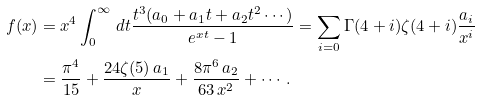<formula> <loc_0><loc_0><loc_500><loc_500>f ( x ) & = x ^ { 4 } \int _ { 0 } ^ { \infty } \, d t \frac { t ^ { 3 } ( a _ { 0 } + a _ { 1 } t + a _ { 2 } t ^ { 2 } \cdots ) } { e ^ { x t } - 1 } = \sum _ { i = 0 } \Gamma ( 4 + i ) \zeta ( 4 + i ) \frac { a _ { i } } { x ^ { i } } \\ & = \frac { \pi ^ { 4 } } { 1 5 } + \frac { 2 4 \zeta ( 5 ) \, a _ { 1 } } { x } + \frac { 8 \pi ^ { 6 } \, a _ { 2 } } { 6 3 \, x ^ { 2 } } + \cdots \, .</formula> 